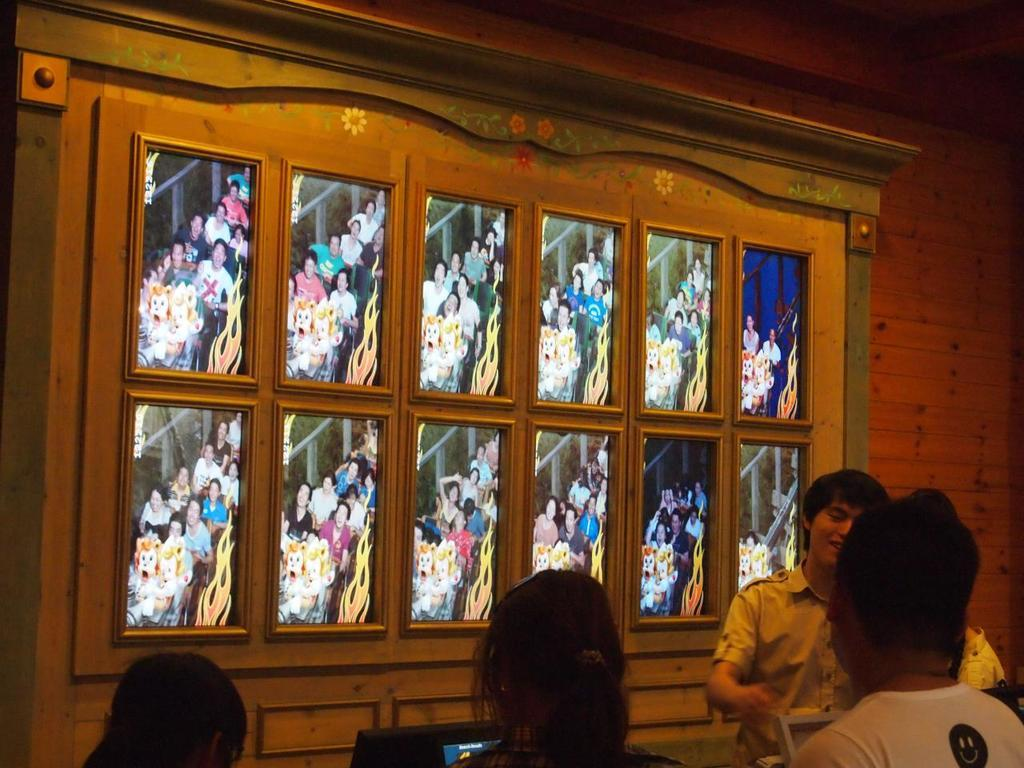How many people are in the image? There are people in the image, but the exact number is not specified. Can you describe the expression of one of the people in the image? Yes, a man is smiling in the image. What can be seen on the wall in the background of the image? There are photo frames on the wall in the background of the image. What color is the skirt worn by the man in the image? There is no mention of a skirt in the image, as the man is not wearing one. 